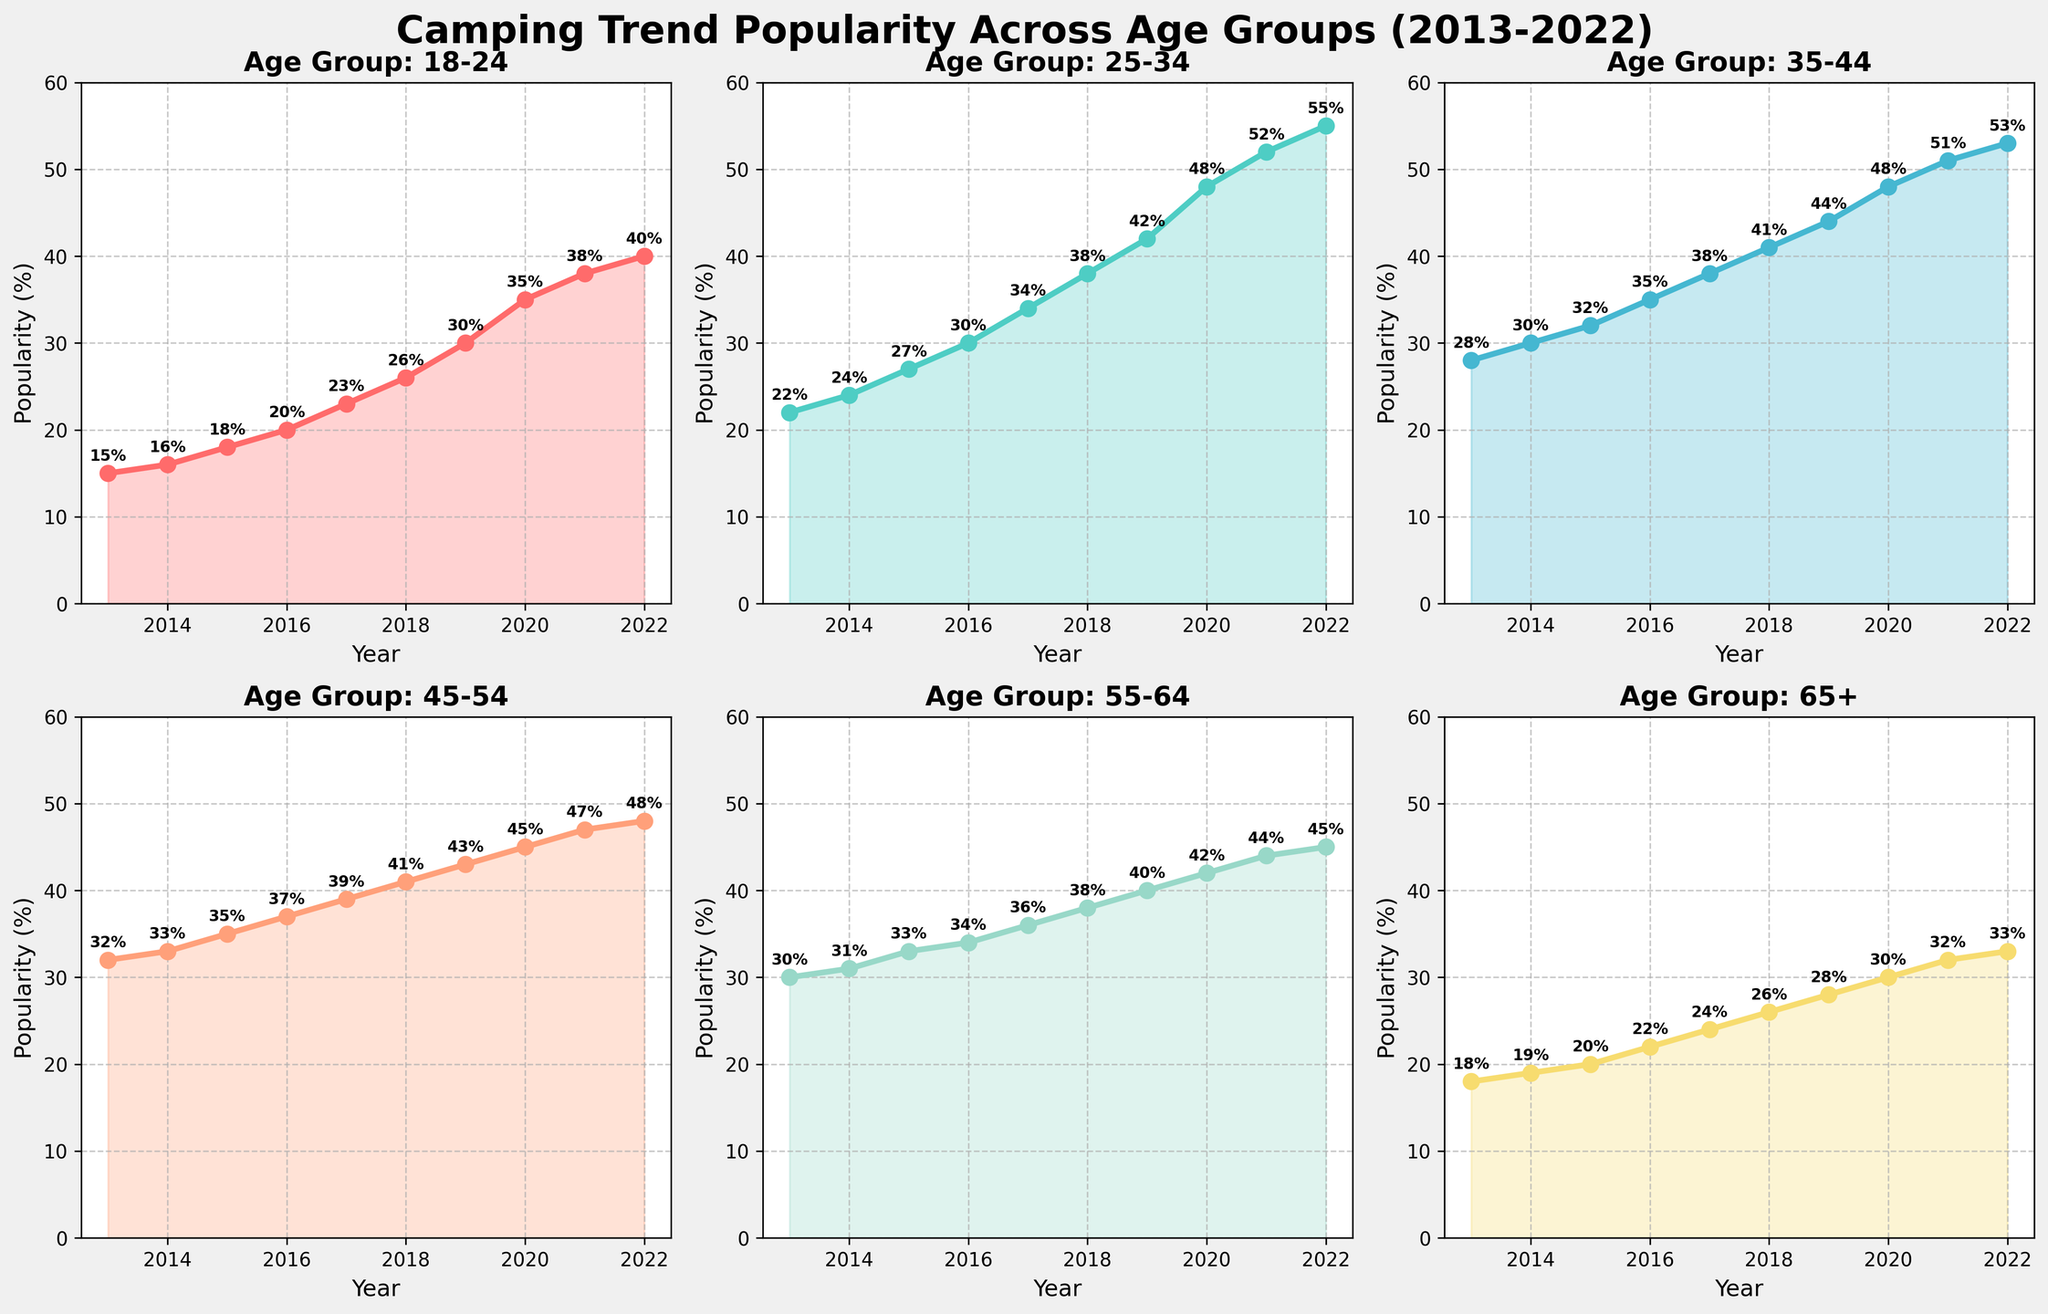What's the title of the figure? The title of the figure is displayed prominently at the top and reads 'Camping Trend Popularity Across Age Groups (2013-2022)'.
Answer: Camping Trend Popularity Across Age Groups (2013-2022) Which age group has the highest popularity in 2022? The line chart for each age group is annotated with the popularity percentage values. The 25-34 age group has the highest value marked at 55%.
Answer: 25-34 In which year did the 18-24 age group's popularity first exceed 20%? By following the 18-24 line chart and annotating values, the year where the popularity first exceeds 20% is 2016 with a value of 20%.
Answer: 2016 What is the difference in popularity between the 35-44 and 55-64 age groups in 2020? Look at the annotated values for both age groups in 2020; the 35-44 age group is at 48% and the 55-64 age group is at 42%. The difference is 48 - 42 = 6%.
Answer: 6% Which age group saw the most significant increase in popularity from 2013 to 2022? Calculate the increase for each group by subtracting the 2013 value from the 2022 value. The 18-24 age group increased by 40 - 15 = 25%. The increases for other groups are: 25-34 (+33%), 35-44 (+25%), 45-54 (+16%), 55-64 (+15%), 65+ (+15%). The largest increase is in the 25-34 age group.
Answer: 25-34 What is the average popularity of the 45-54 age group from 2013 to 2022? Sum the values for the 45-54 age group from 2013 to 2022 and divide by the number of years. (32 + 33 + 35 + 37 + 39 + 41 + 43 + 45 + 47 + 48) / 10 = 40.
Answer: 40 Did the 65+ age group's popularity ever fall below 20% during the decade? By checking the annotated values over the years for the 65+ age group, it remained below 20% until 2015, was exactly 20% in 2015, and rose above 20% thereafter.
Answer: Yes Which two age groups had the same popularity value in any specific year? Checking the graphs and values, in 2020, both the 35-44 and 45-54 age groups had identical popularity values of 48%.
Answer: 35-44 and 45-54 in 2020 What trend can be observed in the popularity for the 25-34 age group over the decade? Observing the 25-34 age group's chart, the trend shows a consistent and significant increase in popularity from 22% in 2013 to 55% in 2022.
Answer: Consistent increase 